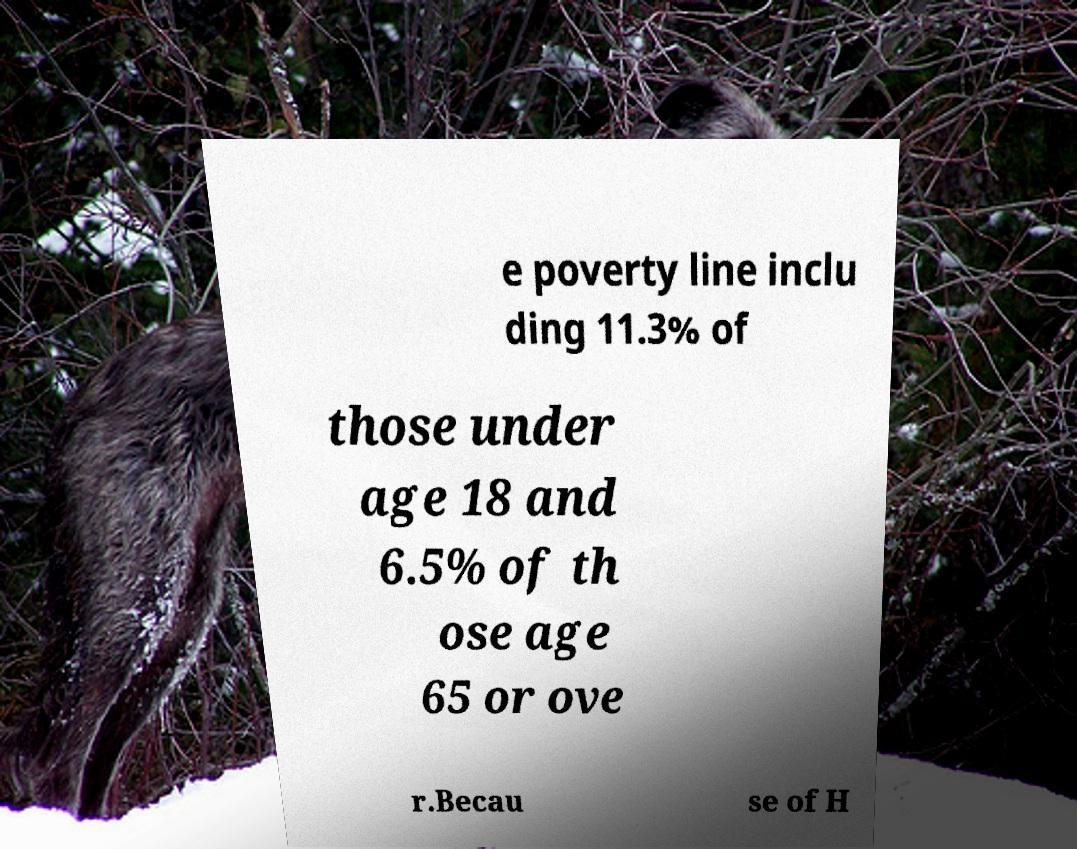I need the written content from this picture converted into text. Can you do that? e poverty line inclu ding 11.3% of those under age 18 and 6.5% of th ose age 65 or ove r.Becau se of H 